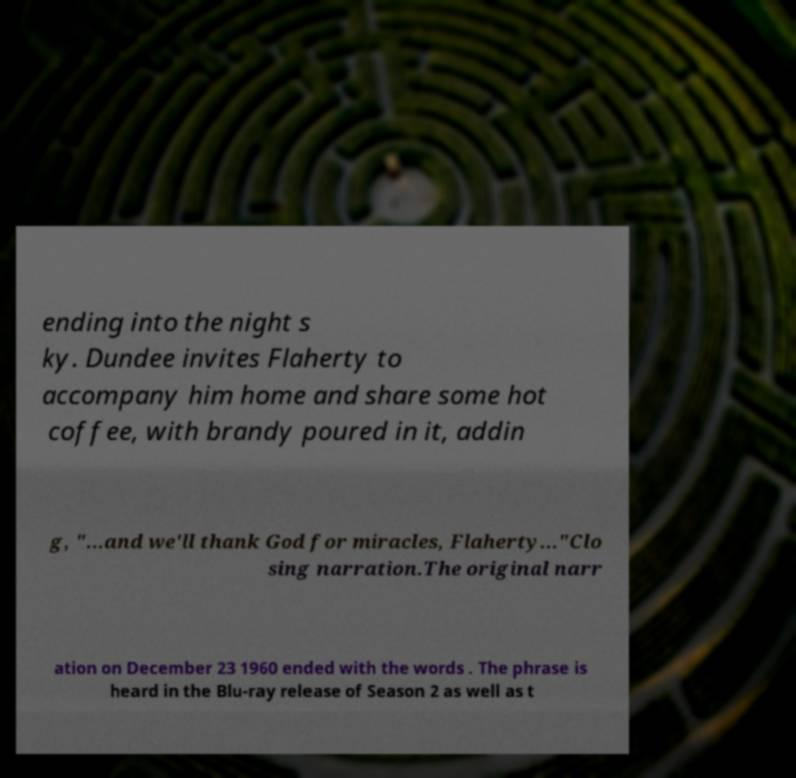Could you assist in decoding the text presented in this image and type it out clearly? ending into the night s ky. Dundee invites Flaherty to accompany him home and share some hot coffee, with brandy poured in it, addin g, "...and we'll thank God for miracles, Flaherty..."Clo sing narration.The original narr ation on December 23 1960 ended with the words . The phrase is heard in the Blu-ray release of Season 2 as well as t 